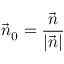<formula> <loc_0><loc_0><loc_500><loc_500>{ \vec { n } } _ { 0 } = { \frac { \vec { n } } { | { \vec { n } } | } }</formula> 